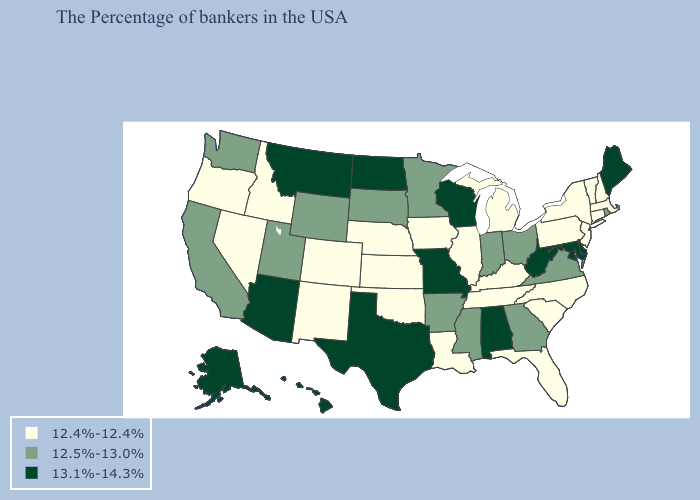What is the value of Mississippi?
Concise answer only. 12.5%-13.0%. What is the lowest value in states that border New Mexico?
Concise answer only. 12.4%-12.4%. What is the lowest value in states that border Nebraska?
Quick response, please. 12.4%-12.4%. Among the states that border Montana , which have the highest value?
Quick response, please. North Dakota. What is the value of South Carolina?
Keep it brief. 12.4%-12.4%. What is the highest value in states that border North Carolina?
Be succinct. 12.5%-13.0%. Does Pennsylvania have the lowest value in the Northeast?
Give a very brief answer. Yes. What is the highest value in the USA?
Be succinct. 13.1%-14.3%. What is the value of Kentucky?
Be succinct. 12.4%-12.4%. Name the states that have a value in the range 13.1%-14.3%?
Be succinct. Maine, Delaware, Maryland, West Virginia, Alabama, Wisconsin, Missouri, Texas, North Dakota, Montana, Arizona, Alaska, Hawaii. Does Delaware have the lowest value in the USA?
Concise answer only. No. Does Wisconsin have the highest value in the MidWest?
Keep it brief. Yes. Name the states that have a value in the range 13.1%-14.3%?
Answer briefly. Maine, Delaware, Maryland, West Virginia, Alabama, Wisconsin, Missouri, Texas, North Dakota, Montana, Arizona, Alaska, Hawaii. Does New Jersey have the lowest value in the USA?
Be succinct. Yes. What is the value of Idaho?
Answer briefly. 12.4%-12.4%. 